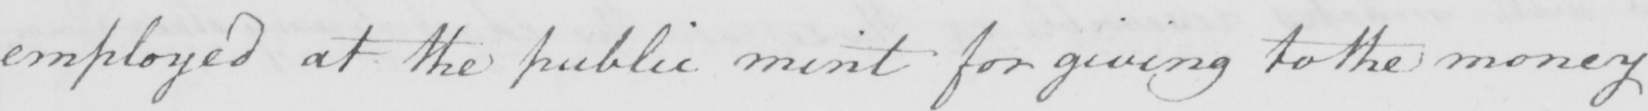Please transcribe the handwritten text in this image. employed at the public mint for giving to the money 